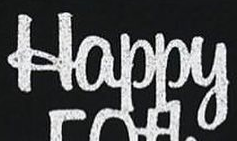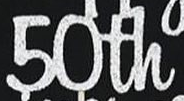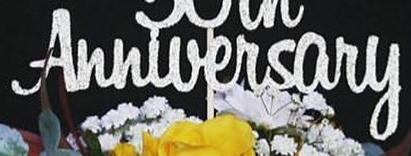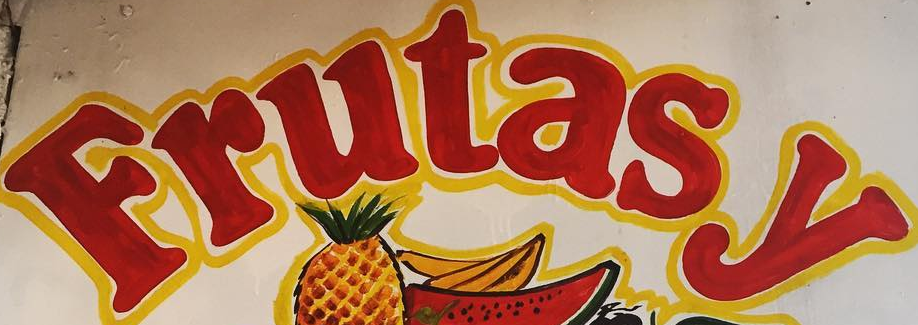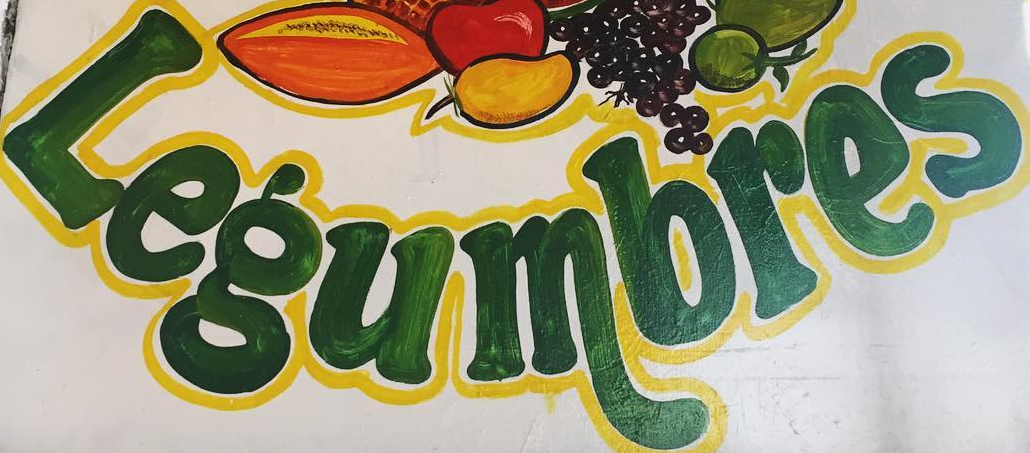Identify the words shown in these images in order, separated by a semicolon. Happy; 50th; Anniversary; Frutasy; Legumbres 